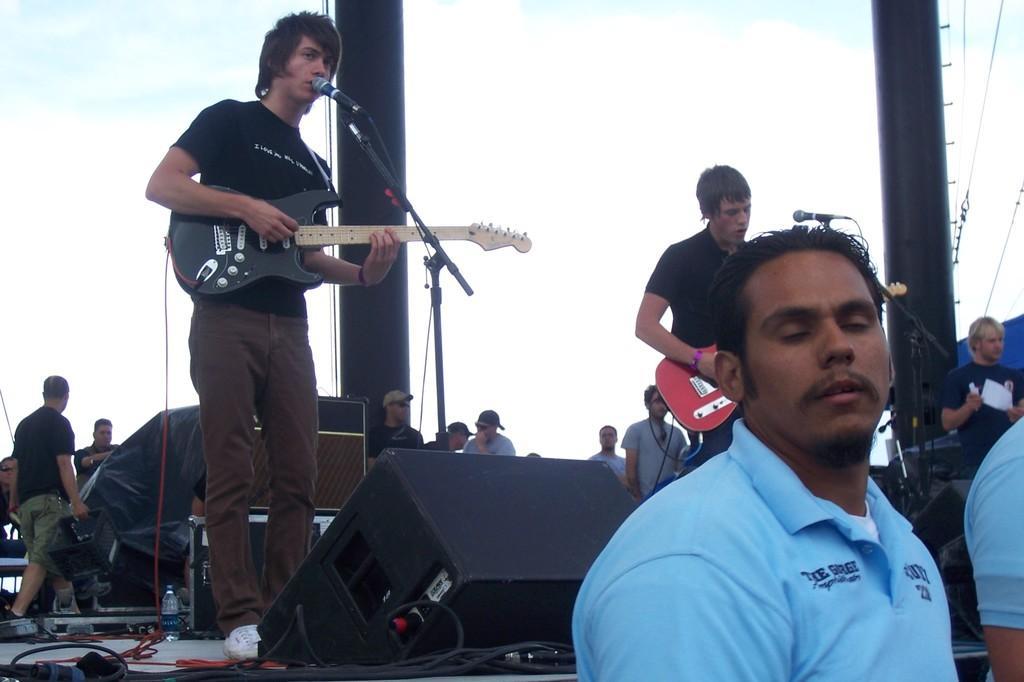Please provide a concise description of this image. This image looks like it is clicked in a concert. There are many people in this image. To the left, there is a man standing, wearing black t-shirt and singing in the mic. He is also playing a guitar. In the front, there is a man wearing blue t-shirt. There is a speaker behind him. To the right, there is a pole and wires are attached to it. 